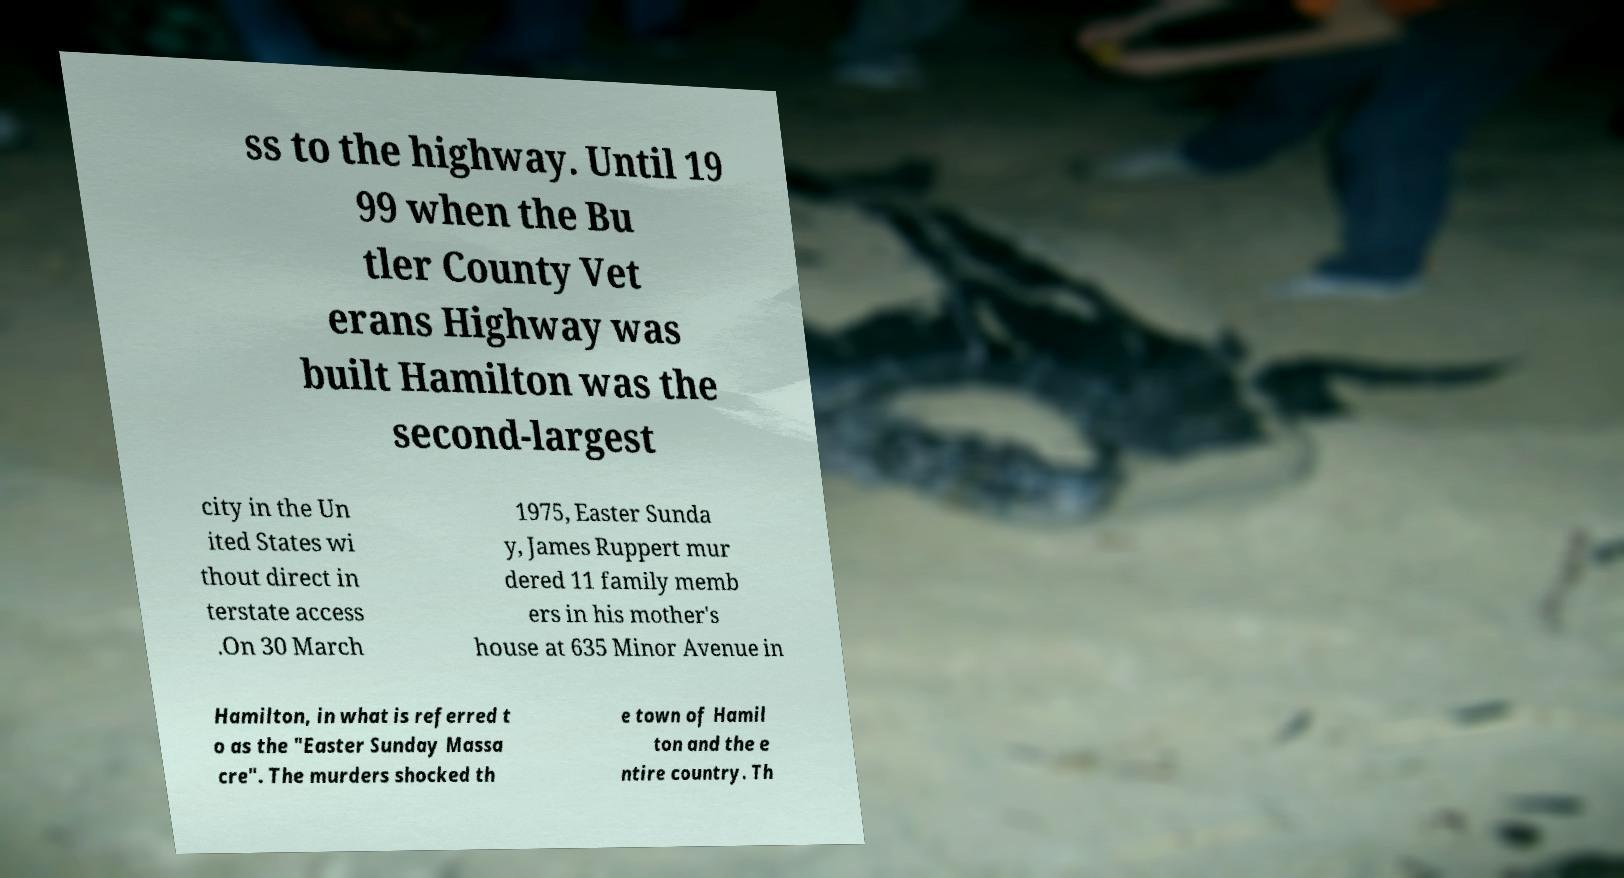Could you extract and type out the text from this image? ss to the highway. Until 19 99 when the Bu tler County Vet erans Highway was built Hamilton was the second-largest city in the Un ited States wi thout direct in terstate access .On 30 March 1975, Easter Sunda y, James Ruppert mur dered 11 family memb ers in his mother's house at 635 Minor Avenue in Hamilton, in what is referred t o as the "Easter Sunday Massa cre". The murders shocked th e town of Hamil ton and the e ntire country. Th 